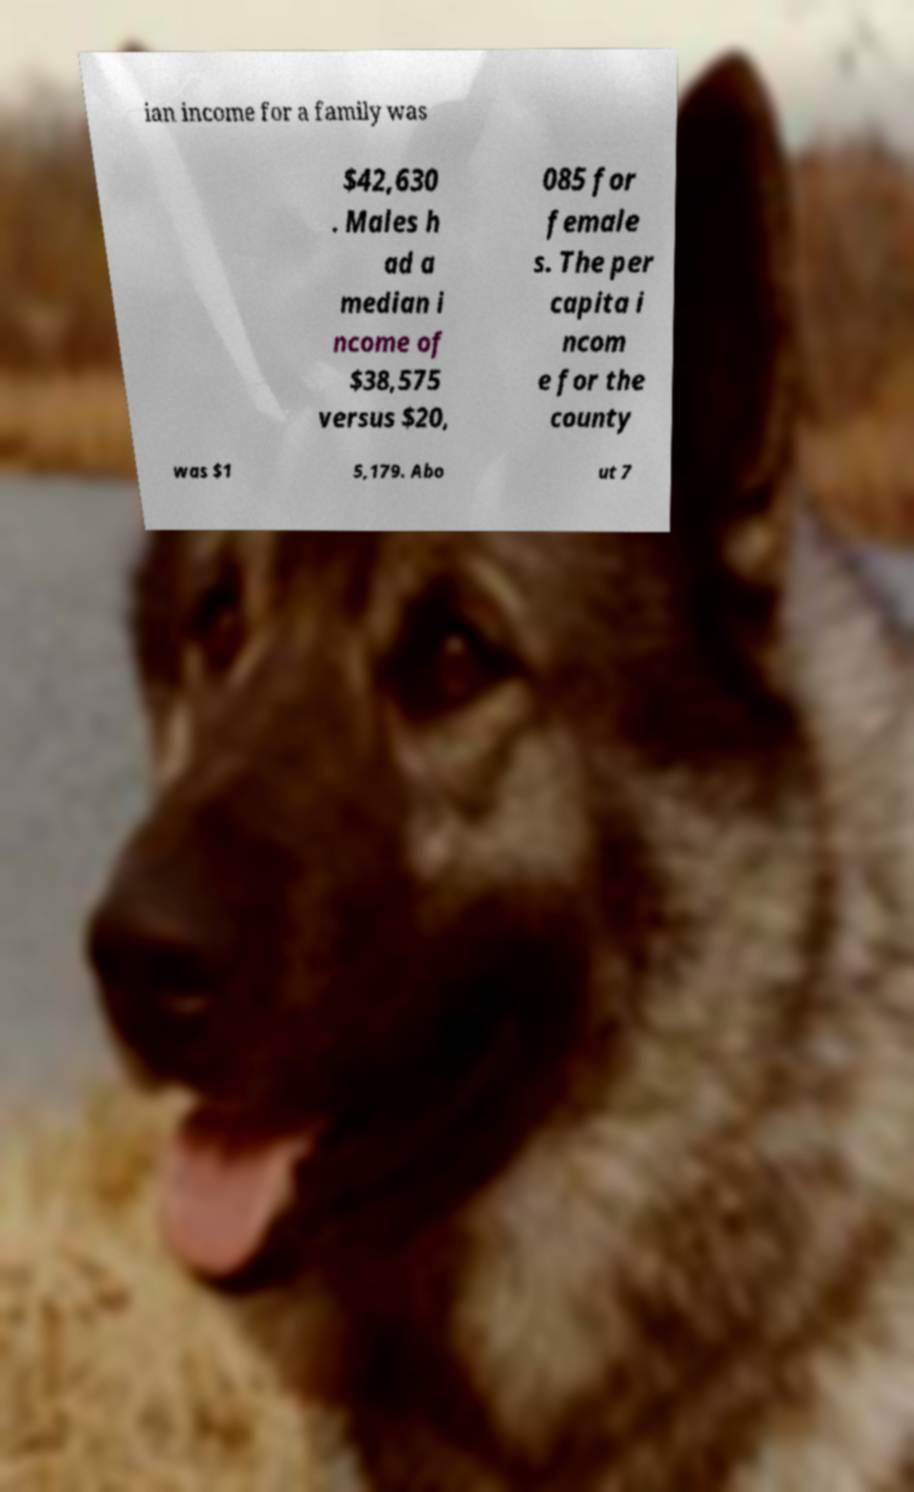Can you read and provide the text displayed in the image?This photo seems to have some interesting text. Can you extract and type it out for me? ian income for a family was $42,630 . Males h ad a median i ncome of $38,575 versus $20, 085 for female s. The per capita i ncom e for the county was $1 5,179. Abo ut 7 